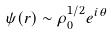<formula> <loc_0><loc_0><loc_500><loc_500>\psi ( r ) \sim \rho _ { 0 } ^ { 1 / 2 } e ^ { i \theta }</formula> 